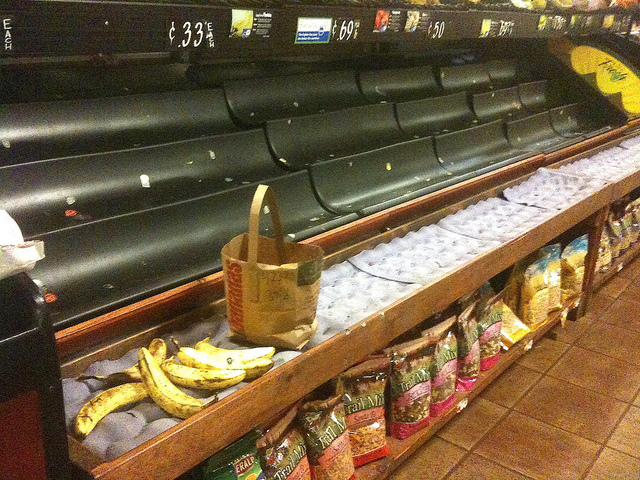Identify the text contained in this image. EACH .33 EARTH 69 50 EARLP 